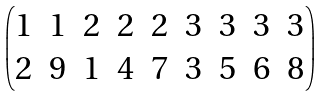<formula> <loc_0><loc_0><loc_500><loc_500>\begin{pmatrix} 1 & 1 & 2 & 2 & 2 & 3 & 3 & 3 & 3 \\ 2 & 9 & 1 & 4 & 7 & 3 & 5 & 6 & 8 \end{pmatrix}</formula> 